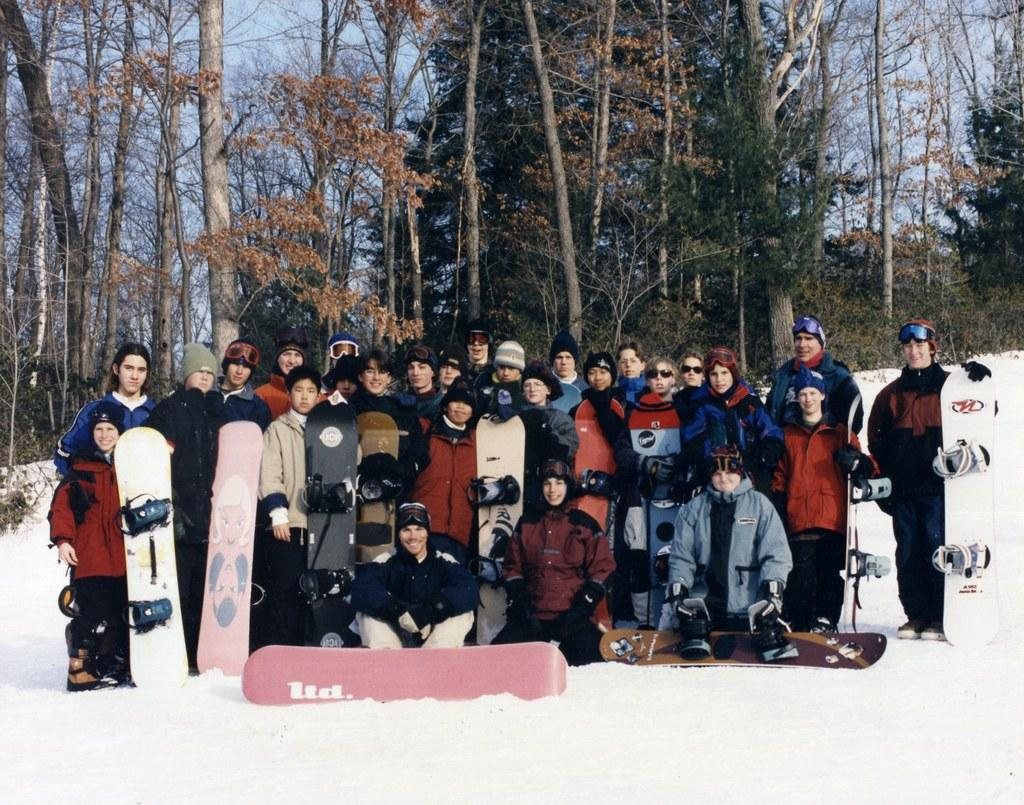How many people are in the image? There is a group of people in the image, but the exact number cannot be determined from the provided facts. What is the weather like in the image? There is snow visible in the image, which suggests a cold and wintry setting. What objects are present in the image that can be used for transportation? Skateboards are present in the image, which can be used for transportation. What can be seen in the background of the image? There are trees and the sky visible in the background of the image. What type of bead is used to decorate the trees in the image? There is no mention of beads or any decorations on the trees in the image. 